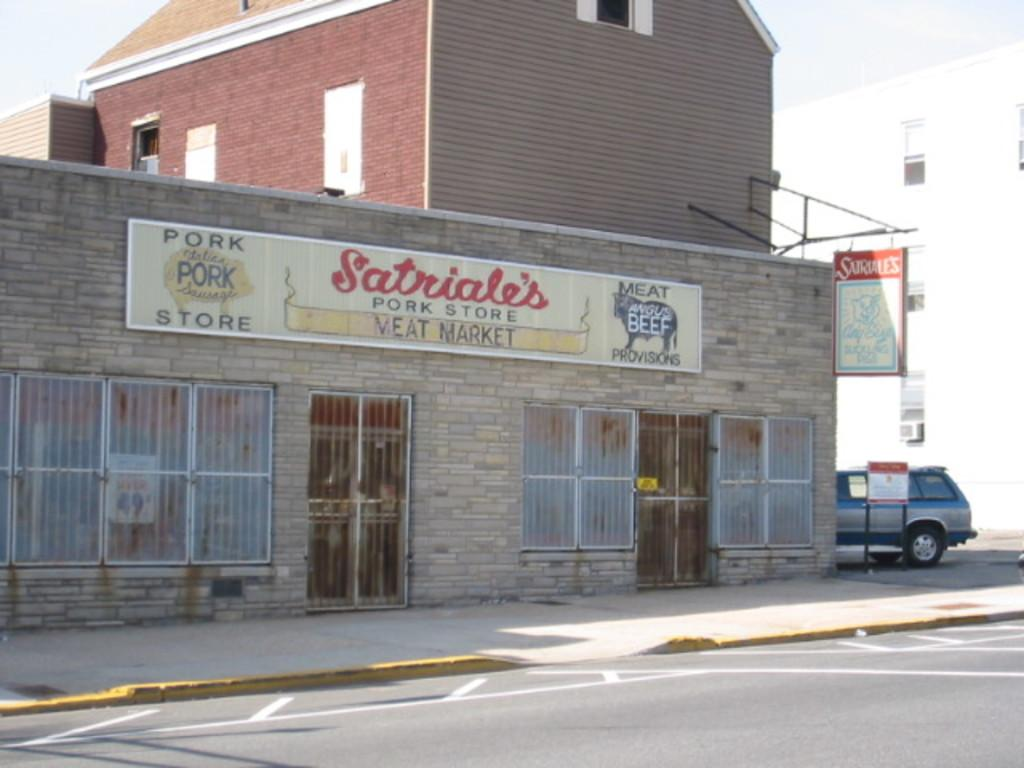What type of structure is in the image? There is a stone building in the image. What else can be seen in the image besides the stone building? There are boards and another building in the image. What can be seen in the background of the image? The sky is visible in the background of the image. How many laborers are working on the stone building in the image? There are no laborers present in the image; it only shows the stone building, boards, and another building. What type of clouds can be seen in the image? There are no clouds visible in the image; only the sky is mentioned in the background. 